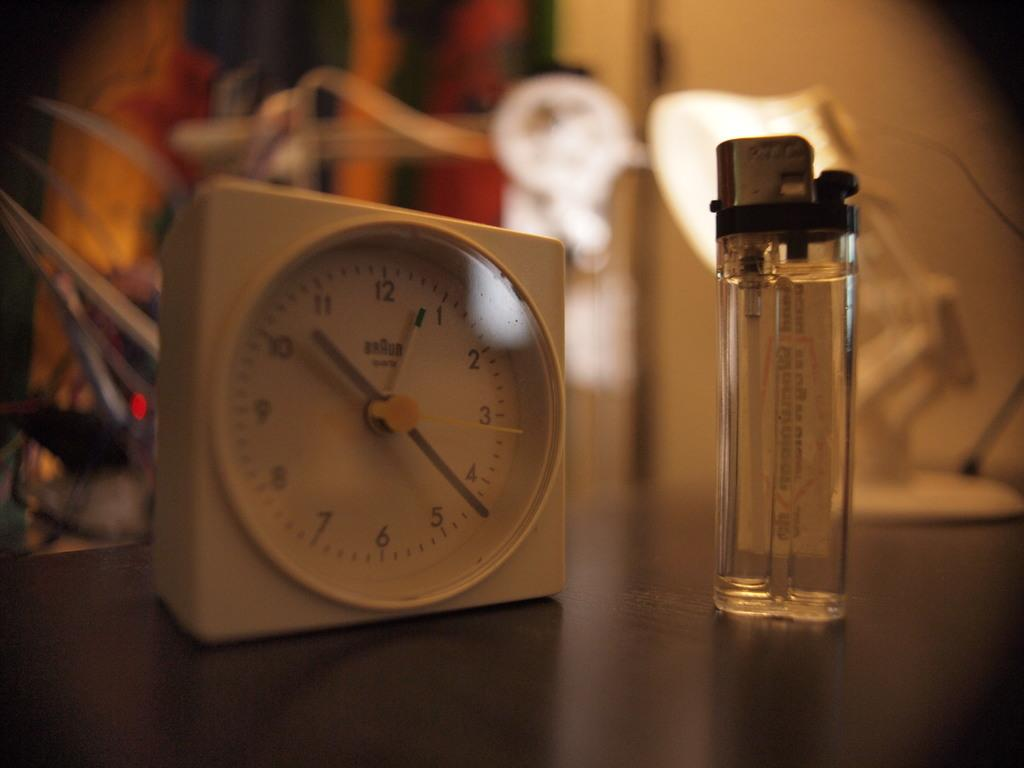<image>
Provide a brief description of the given image. A clock sitting on a table shows a time of 10:22. 